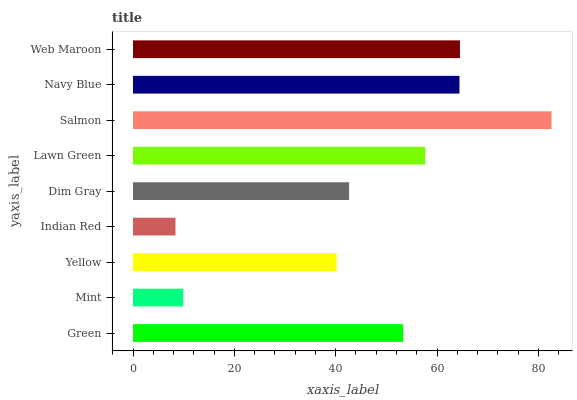Is Indian Red the minimum?
Answer yes or no. Yes. Is Salmon the maximum?
Answer yes or no. Yes. Is Mint the minimum?
Answer yes or no. No. Is Mint the maximum?
Answer yes or no. No. Is Green greater than Mint?
Answer yes or no. Yes. Is Mint less than Green?
Answer yes or no. Yes. Is Mint greater than Green?
Answer yes or no. No. Is Green less than Mint?
Answer yes or no. No. Is Green the high median?
Answer yes or no. Yes. Is Green the low median?
Answer yes or no. Yes. Is Navy Blue the high median?
Answer yes or no. No. Is Lawn Green the low median?
Answer yes or no. No. 